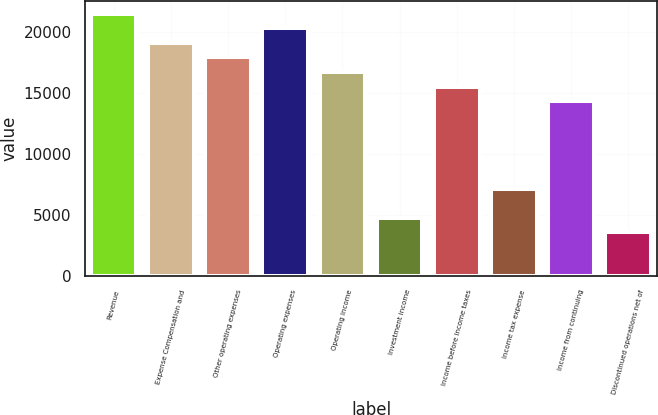Convert chart to OTSL. <chart><loc_0><loc_0><loc_500><loc_500><bar_chart><fcel>Revenue<fcel>Expense Compensation and<fcel>Other operating expenses<fcel>Operating expenses<fcel>Operating income<fcel>Investment income<fcel>Income before income taxes<fcel>Income tax expense<fcel>Income from continuing<fcel>Discontinued operations net of<nl><fcel>21461.5<fcel>19077.2<fcel>17885<fcel>20269.4<fcel>16692.8<fcel>4770.89<fcel>15500.6<fcel>7155.27<fcel>14308.4<fcel>3578.7<nl></chart> 